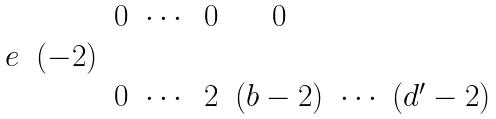<formula> <loc_0><loc_0><loc_500><loc_500>\begin{matrix} & & 0 & \cdots & 0 & 0 & \\ e & ( - 2 ) & & & & & \\ & & 0 & \cdots & 2 & ( b - 2 ) & \cdots \ ( d ^ { \prime } - 2 ) \end{matrix}</formula> 